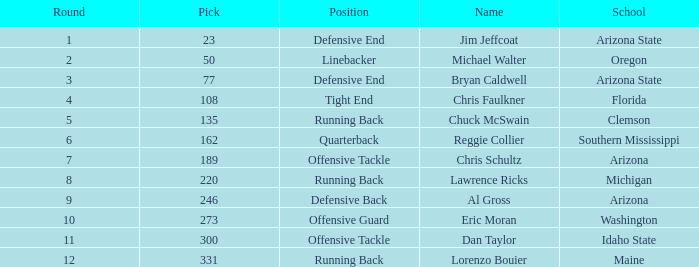What is the number of the pick for round 11? 300.0. 